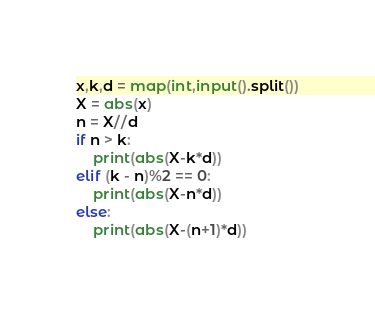<code> <loc_0><loc_0><loc_500><loc_500><_Python_>x,k,d = map(int,input().split())
X = abs(x)
n = X//d
if n > k:
    print(abs(X-k*d))
elif (k - n)%2 == 0:
    print(abs(X-n*d))
else:
    print(abs(X-(n+1)*d))</code> 